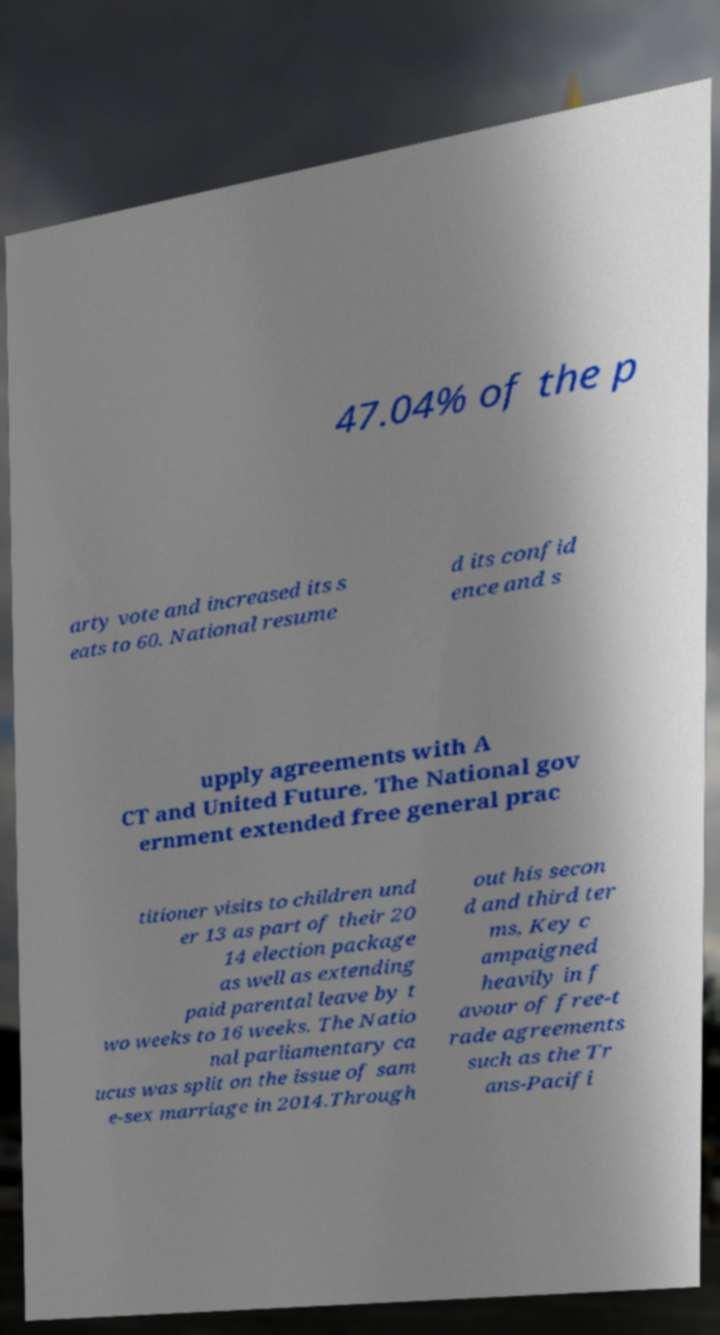Could you extract and type out the text from this image? 47.04% of the p arty vote and increased its s eats to 60. National resume d its confid ence and s upply agreements with A CT and United Future. The National gov ernment extended free general prac titioner visits to children und er 13 as part of their 20 14 election package as well as extending paid parental leave by t wo weeks to 16 weeks. The Natio nal parliamentary ca ucus was split on the issue of sam e-sex marriage in 2014.Through out his secon d and third ter ms, Key c ampaigned heavily in f avour of free-t rade agreements such as the Tr ans-Pacifi 